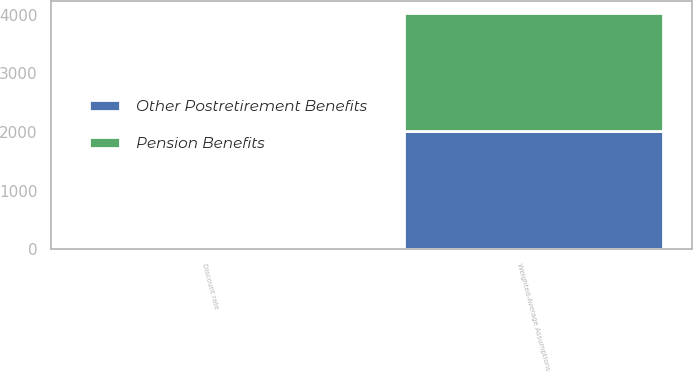<chart> <loc_0><loc_0><loc_500><loc_500><stacked_bar_chart><ecel><fcel>Weighted-Average Assumptions<fcel>Discount rate<nl><fcel>Pension Benefits<fcel>2016<fcel>4.52<nl><fcel>Other Postretirement Benefits<fcel>2016<fcel>4.55<nl></chart> 